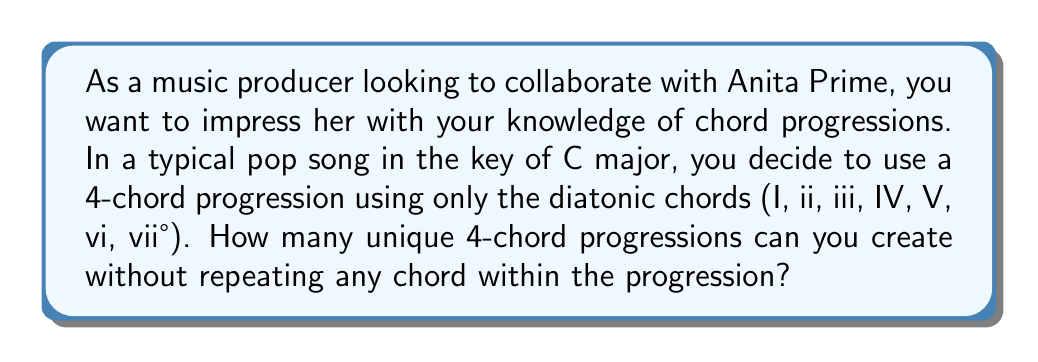Give your solution to this math problem. To solve this problem, we need to use the concept of permutations without repetition. Here's how we can approach it:

1. First, we identify the number of available chords. In the key of C major, we have 7 diatonic chords: I, ii, iii, IV, V, vi, and vii°.

2. We want to create a 4-chord progression without repeating any chord. This means we are selecting 4 chords out of the 7 available chords, where the order matters (since chord progressions are ordered sequences).

3. This scenario is a perfect application of the permutation formula:

   $$P(n,r) = \frac{n!}{(n-r)!}$$

   Where:
   $n$ is the total number of items to choose from (in this case, 7 chords)
   $r$ is the number of items being chosen (in this case, 4 chords)

4. Plugging in our values:

   $$P(7,4) = \frac{7!}{(7-4)!} = \frac{7!}{3!}$$

5. Expanding this:

   $$\frac{7 \times 6 \times 5 \times 4 \times 3!}{3!}$$

6. The 3! cancels out in the numerator and denominator:

   $$7 \times 6 \times 5 \times 4 = 840$$

Therefore, there are 840 unique 4-chord progressions possible using the diatonic chords in the key of C major without repetition.
Answer: 840 unique 4-chord progressions 